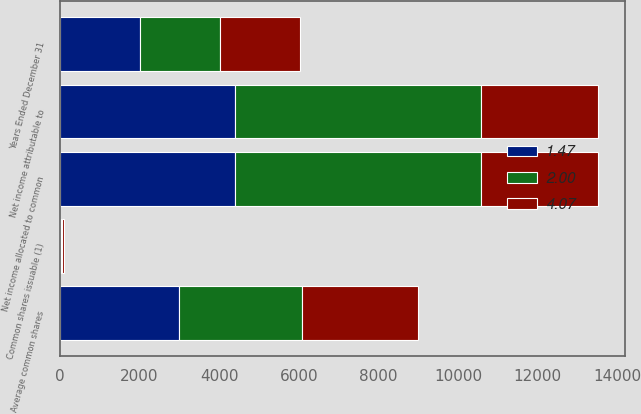Convert chart. <chart><loc_0><loc_0><loc_500><loc_500><stacked_bar_chart><ecel><fcel>Years Ended December 31<fcel>Net income attributable to<fcel>Net income allocated to common<fcel>Average common shares<fcel>Common shares issuable (1)<nl><fcel>4.07<fcel>2014<fcel>2945.5<fcel>2945.5<fcel>2928<fcel>34<nl><fcel>1.47<fcel>2013<fcel>4404<fcel>4404<fcel>2996<fcel>33<nl><fcel>2<fcel>2012<fcel>6168<fcel>6165<fcel>3076<fcel>35<nl></chart> 